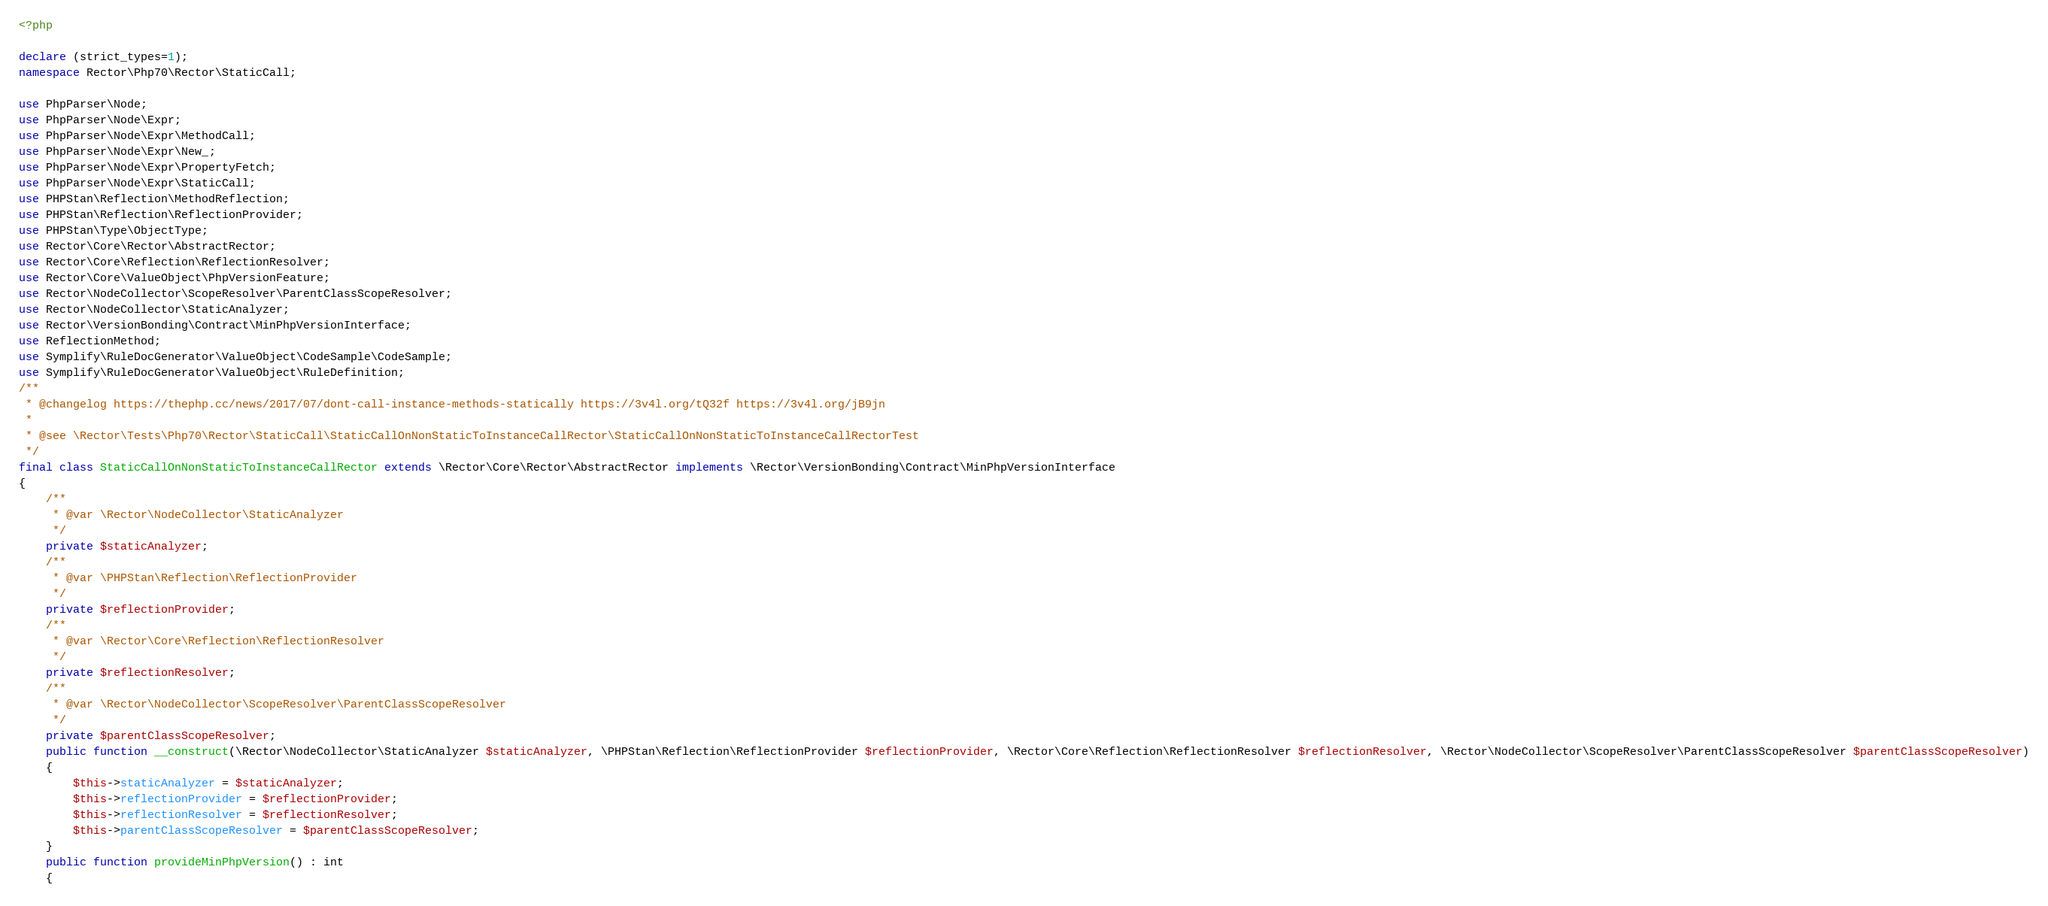<code> <loc_0><loc_0><loc_500><loc_500><_PHP_><?php

declare (strict_types=1);
namespace Rector\Php70\Rector\StaticCall;

use PhpParser\Node;
use PhpParser\Node\Expr;
use PhpParser\Node\Expr\MethodCall;
use PhpParser\Node\Expr\New_;
use PhpParser\Node\Expr\PropertyFetch;
use PhpParser\Node\Expr\StaticCall;
use PHPStan\Reflection\MethodReflection;
use PHPStan\Reflection\ReflectionProvider;
use PHPStan\Type\ObjectType;
use Rector\Core\Rector\AbstractRector;
use Rector\Core\Reflection\ReflectionResolver;
use Rector\Core\ValueObject\PhpVersionFeature;
use Rector\NodeCollector\ScopeResolver\ParentClassScopeResolver;
use Rector\NodeCollector\StaticAnalyzer;
use Rector\VersionBonding\Contract\MinPhpVersionInterface;
use ReflectionMethod;
use Symplify\RuleDocGenerator\ValueObject\CodeSample\CodeSample;
use Symplify\RuleDocGenerator\ValueObject\RuleDefinition;
/**
 * @changelog https://thephp.cc/news/2017/07/dont-call-instance-methods-statically https://3v4l.org/tQ32f https://3v4l.org/jB9jn
 *
 * @see \Rector\Tests\Php70\Rector\StaticCall\StaticCallOnNonStaticToInstanceCallRector\StaticCallOnNonStaticToInstanceCallRectorTest
 */
final class StaticCallOnNonStaticToInstanceCallRector extends \Rector\Core\Rector\AbstractRector implements \Rector\VersionBonding\Contract\MinPhpVersionInterface
{
    /**
     * @var \Rector\NodeCollector\StaticAnalyzer
     */
    private $staticAnalyzer;
    /**
     * @var \PHPStan\Reflection\ReflectionProvider
     */
    private $reflectionProvider;
    /**
     * @var \Rector\Core\Reflection\ReflectionResolver
     */
    private $reflectionResolver;
    /**
     * @var \Rector\NodeCollector\ScopeResolver\ParentClassScopeResolver
     */
    private $parentClassScopeResolver;
    public function __construct(\Rector\NodeCollector\StaticAnalyzer $staticAnalyzer, \PHPStan\Reflection\ReflectionProvider $reflectionProvider, \Rector\Core\Reflection\ReflectionResolver $reflectionResolver, \Rector\NodeCollector\ScopeResolver\ParentClassScopeResolver $parentClassScopeResolver)
    {
        $this->staticAnalyzer = $staticAnalyzer;
        $this->reflectionProvider = $reflectionProvider;
        $this->reflectionResolver = $reflectionResolver;
        $this->parentClassScopeResolver = $parentClassScopeResolver;
    }
    public function provideMinPhpVersion() : int
    {</code> 